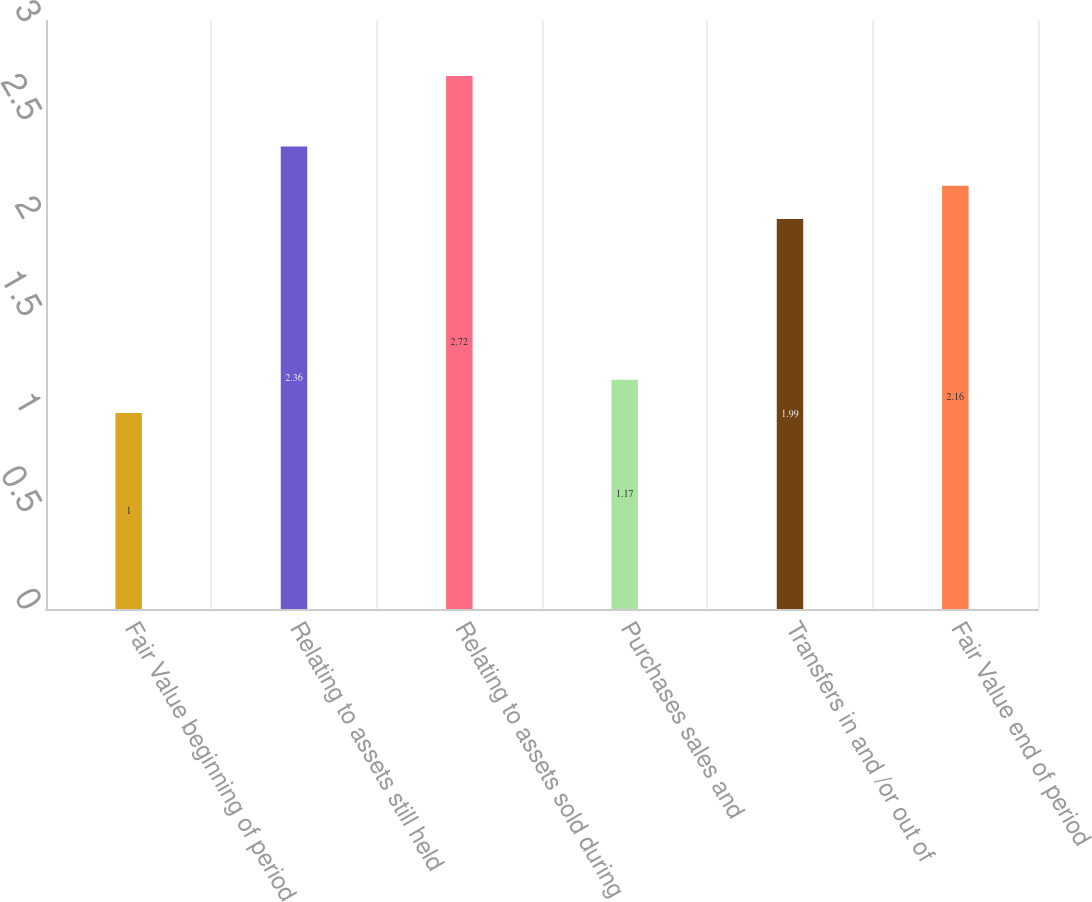Convert chart to OTSL. <chart><loc_0><loc_0><loc_500><loc_500><bar_chart><fcel>Fair Value beginning of period<fcel>Relating to assets still held<fcel>Relating to assets sold during<fcel>Purchases sales and<fcel>Transfers in and /or out of<fcel>Fair Value end of period<nl><fcel>1<fcel>2.36<fcel>2.72<fcel>1.17<fcel>1.99<fcel>2.16<nl></chart> 